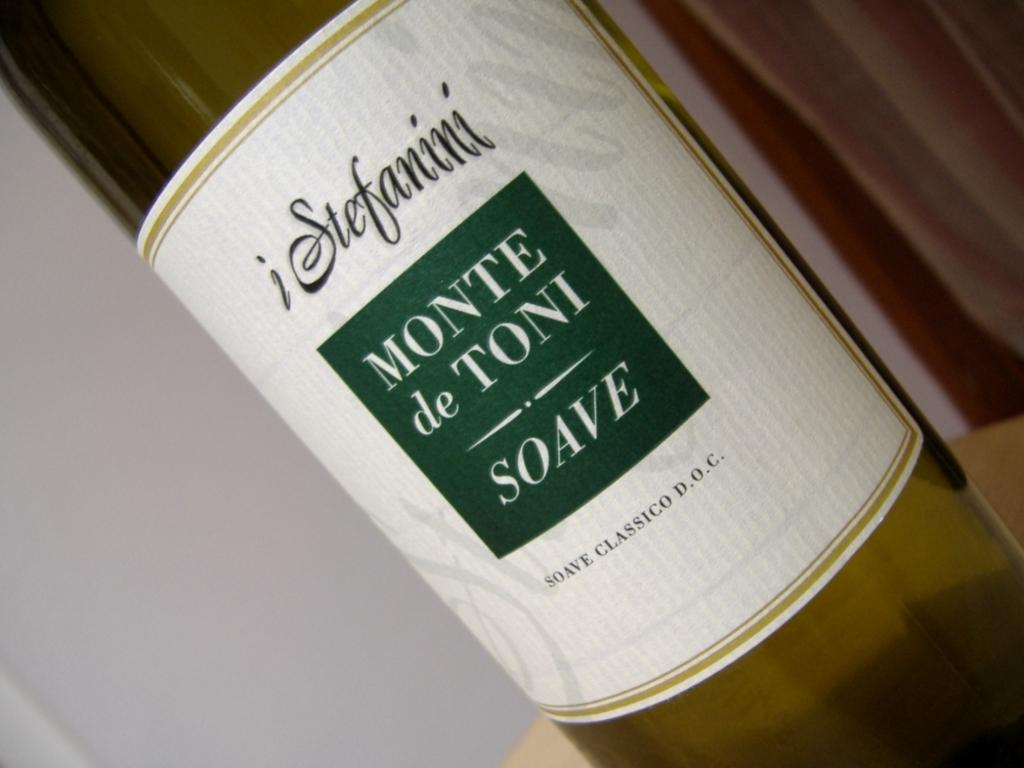What object can be seen in the image? There is a bottle in the image. What songs are being sung by the bottle in the image? There are no songs being sung by the bottle in the image, as it is an inanimate object and cannot sing. 